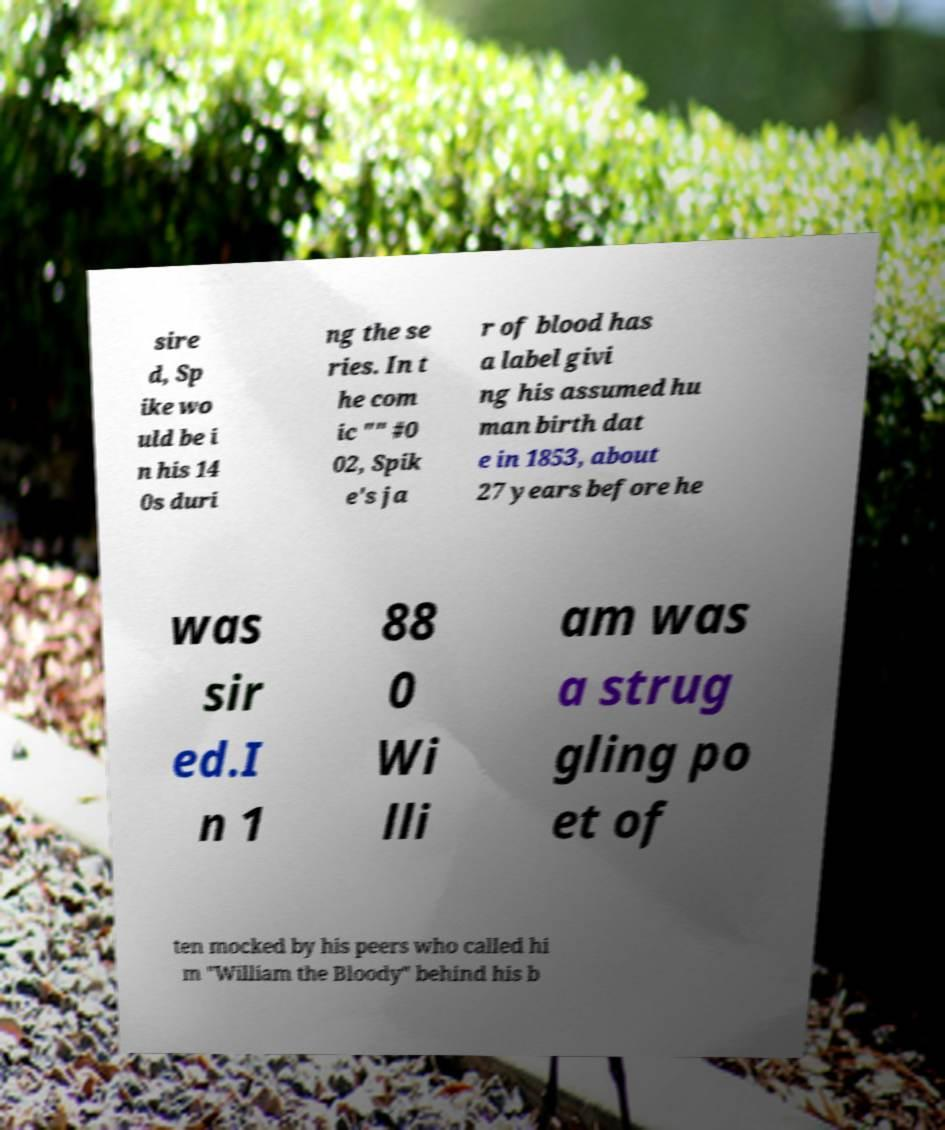I need the written content from this picture converted into text. Can you do that? sire d, Sp ike wo uld be i n his 14 0s duri ng the se ries. In t he com ic "" #0 02, Spik e's ja r of blood has a label givi ng his assumed hu man birth dat e in 1853, about 27 years before he was sir ed.I n 1 88 0 Wi lli am was a strug gling po et of ten mocked by his peers who called hi m "William the Bloody" behind his b 